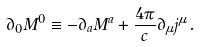<formula> <loc_0><loc_0><loc_500><loc_500>\partial _ { 0 } M ^ { 0 } \equiv - \partial _ { a } M ^ { a } + \frac { 4 \pi } { c } \partial _ { \mu } j ^ { \mu } \, .</formula> 